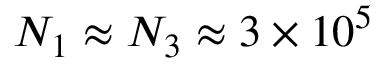<formula> <loc_0><loc_0><loc_500><loc_500>N _ { 1 } \approx N _ { 3 } \approx 3 \times 1 0 ^ { 5 }</formula> 